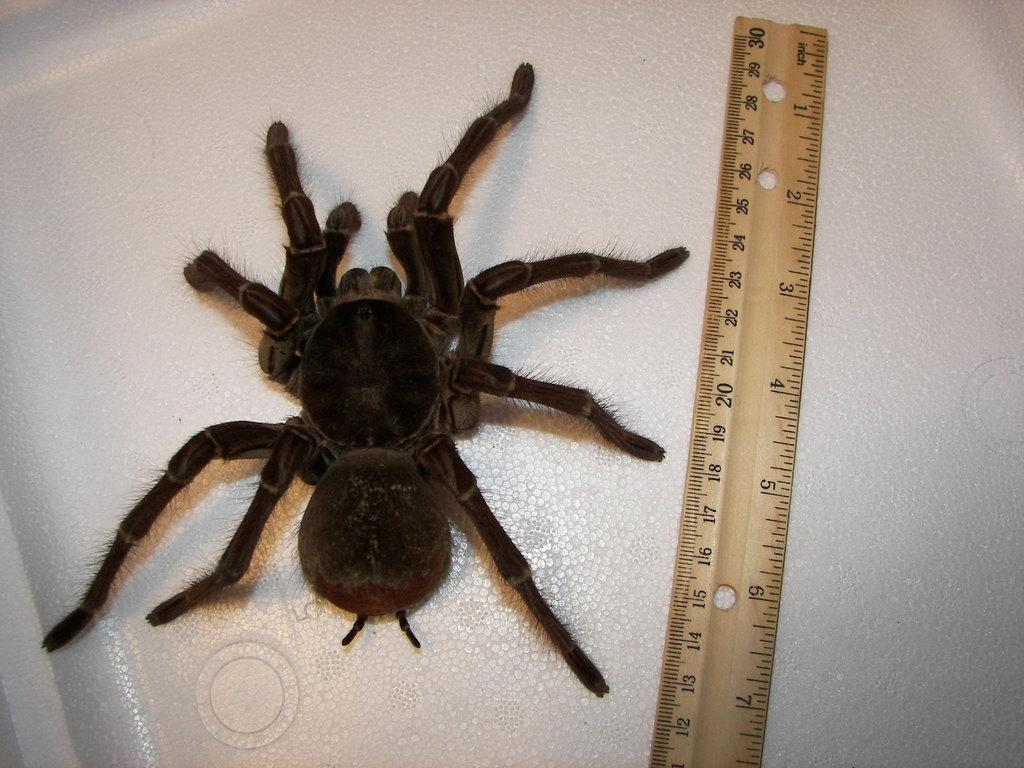What is the main subject of the image? The main subject of the image is a spider. What object is present in the image that can be used for measuring? There is a measuring scale in the image. What type of surface is visible in the image? The white surface is present in the image. What type of treatment is the spider receiving in the image? There is no indication in the image that the spider is receiving any treatment. What type of leaf can be seen in the image? There is no leaf present in the image. What type of oil is visible in the image? There is no oil present in the image. 